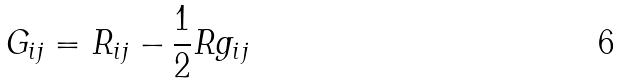<formula> <loc_0><loc_0><loc_500><loc_500>G _ { i j } = R _ { i j } - \frac { 1 } { 2 } R g _ { i j }</formula> 